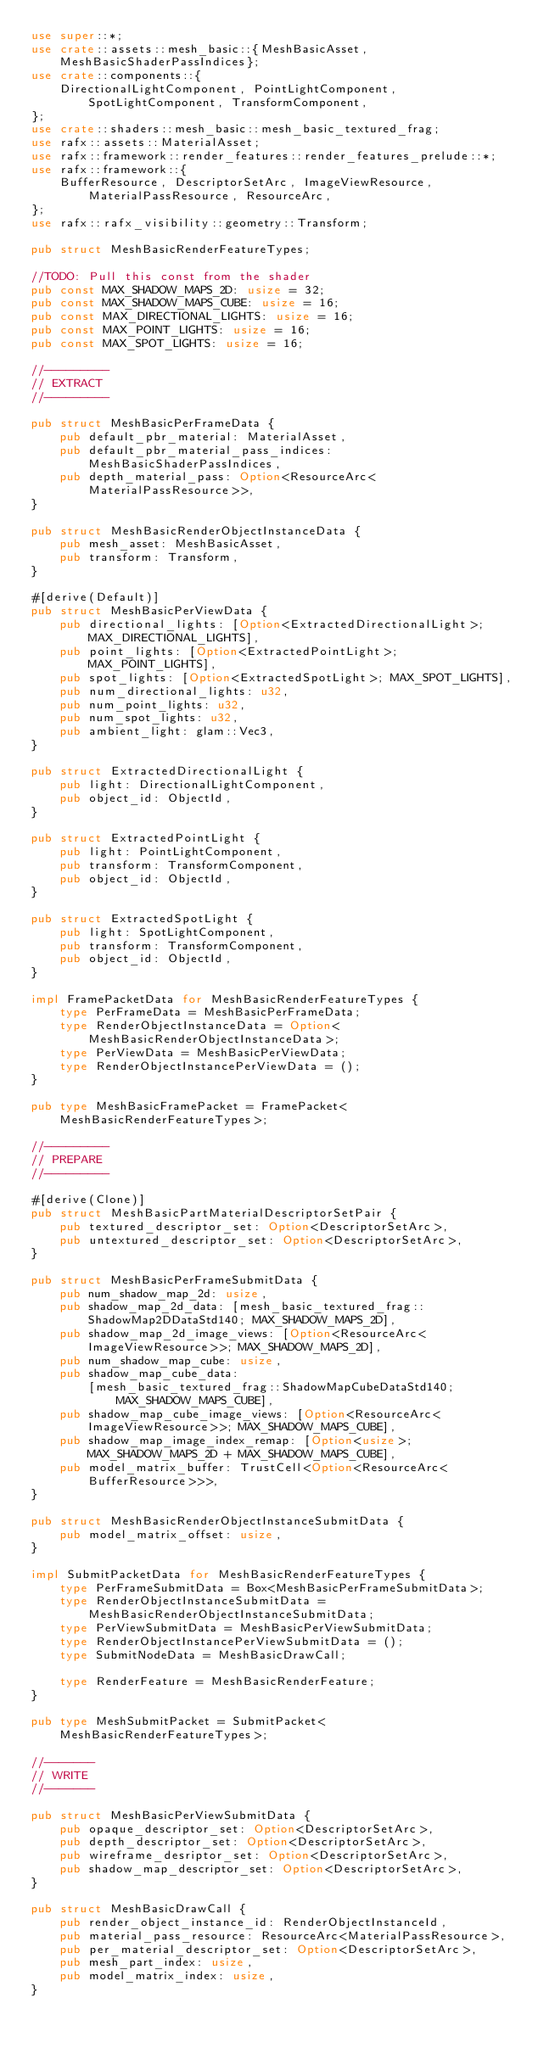<code> <loc_0><loc_0><loc_500><loc_500><_Rust_>use super::*;
use crate::assets::mesh_basic::{MeshBasicAsset, MeshBasicShaderPassIndices};
use crate::components::{
    DirectionalLightComponent, PointLightComponent, SpotLightComponent, TransformComponent,
};
use crate::shaders::mesh_basic::mesh_basic_textured_frag;
use rafx::assets::MaterialAsset;
use rafx::framework::render_features::render_features_prelude::*;
use rafx::framework::{
    BufferResource, DescriptorSetArc, ImageViewResource, MaterialPassResource, ResourceArc,
};
use rafx::rafx_visibility::geometry::Transform;

pub struct MeshBasicRenderFeatureTypes;

//TODO: Pull this const from the shader
pub const MAX_SHADOW_MAPS_2D: usize = 32;
pub const MAX_SHADOW_MAPS_CUBE: usize = 16;
pub const MAX_DIRECTIONAL_LIGHTS: usize = 16;
pub const MAX_POINT_LIGHTS: usize = 16;
pub const MAX_SPOT_LIGHTS: usize = 16;

//---------
// EXTRACT
//---------

pub struct MeshBasicPerFrameData {
    pub default_pbr_material: MaterialAsset,
    pub default_pbr_material_pass_indices: MeshBasicShaderPassIndices,
    pub depth_material_pass: Option<ResourceArc<MaterialPassResource>>,
}

pub struct MeshBasicRenderObjectInstanceData {
    pub mesh_asset: MeshBasicAsset,
    pub transform: Transform,
}

#[derive(Default)]
pub struct MeshBasicPerViewData {
    pub directional_lights: [Option<ExtractedDirectionalLight>; MAX_DIRECTIONAL_LIGHTS],
    pub point_lights: [Option<ExtractedPointLight>; MAX_POINT_LIGHTS],
    pub spot_lights: [Option<ExtractedSpotLight>; MAX_SPOT_LIGHTS],
    pub num_directional_lights: u32,
    pub num_point_lights: u32,
    pub num_spot_lights: u32,
    pub ambient_light: glam::Vec3,
}

pub struct ExtractedDirectionalLight {
    pub light: DirectionalLightComponent,
    pub object_id: ObjectId,
}

pub struct ExtractedPointLight {
    pub light: PointLightComponent,
    pub transform: TransformComponent,
    pub object_id: ObjectId,
}

pub struct ExtractedSpotLight {
    pub light: SpotLightComponent,
    pub transform: TransformComponent,
    pub object_id: ObjectId,
}

impl FramePacketData for MeshBasicRenderFeatureTypes {
    type PerFrameData = MeshBasicPerFrameData;
    type RenderObjectInstanceData = Option<MeshBasicRenderObjectInstanceData>;
    type PerViewData = MeshBasicPerViewData;
    type RenderObjectInstancePerViewData = ();
}

pub type MeshBasicFramePacket = FramePacket<MeshBasicRenderFeatureTypes>;

//---------
// PREPARE
//---------

#[derive(Clone)]
pub struct MeshBasicPartMaterialDescriptorSetPair {
    pub textured_descriptor_set: Option<DescriptorSetArc>,
    pub untextured_descriptor_set: Option<DescriptorSetArc>,
}

pub struct MeshBasicPerFrameSubmitData {
    pub num_shadow_map_2d: usize,
    pub shadow_map_2d_data: [mesh_basic_textured_frag::ShadowMap2DDataStd140; MAX_SHADOW_MAPS_2D],
    pub shadow_map_2d_image_views: [Option<ResourceArc<ImageViewResource>>; MAX_SHADOW_MAPS_2D],
    pub num_shadow_map_cube: usize,
    pub shadow_map_cube_data:
        [mesh_basic_textured_frag::ShadowMapCubeDataStd140; MAX_SHADOW_MAPS_CUBE],
    pub shadow_map_cube_image_views: [Option<ResourceArc<ImageViewResource>>; MAX_SHADOW_MAPS_CUBE],
    pub shadow_map_image_index_remap: [Option<usize>; MAX_SHADOW_MAPS_2D + MAX_SHADOW_MAPS_CUBE],
    pub model_matrix_buffer: TrustCell<Option<ResourceArc<BufferResource>>>,
}

pub struct MeshBasicRenderObjectInstanceSubmitData {
    pub model_matrix_offset: usize,
}

impl SubmitPacketData for MeshBasicRenderFeatureTypes {
    type PerFrameSubmitData = Box<MeshBasicPerFrameSubmitData>;
    type RenderObjectInstanceSubmitData = MeshBasicRenderObjectInstanceSubmitData;
    type PerViewSubmitData = MeshBasicPerViewSubmitData;
    type RenderObjectInstancePerViewSubmitData = ();
    type SubmitNodeData = MeshBasicDrawCall;

    type RenderFeature = MeshBasicRenderFeature;
}

pub type MeshSubmitPacket = SubmitPacket<MeshBasicRenderFeatureTypes>;

//-------
// WRITE
//-------

pub struct MeshBasicPerViewSubmitData {
    pub opaque_descriptor_set: Option<DescriptorSetArc>,
    pub depth_descriptor_set: Option<DescriptorSetArc>,
    pub wireframe_desriptor_set: Option<DescriptorSetArc>,
    pub shadow_map_descriptor_set: Option<DescriptorSetArc>,
}

pub struct MeshBasicDrawCall {
    pub render_object_instance_id: RenderObjectInstanceId,
    pub material_pass_resource: ResourceArc<MaterialPassResource>,
    pub per_material_descriptor_set: Option<DescriptorSetArc>,
    pub mesh_part_index: usize,
    pub model_matrix_index: usize,
}
</code> 